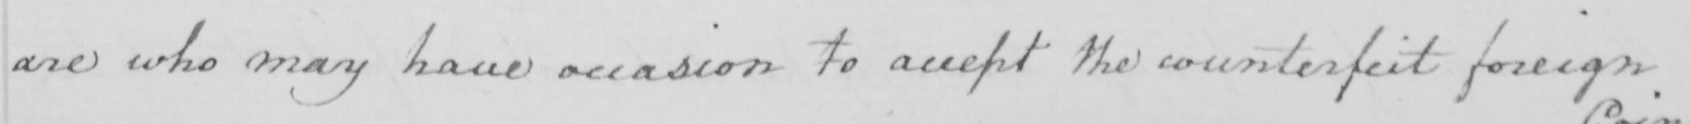Can you tell me what this handwritten text says? are who may have occasion to accept the counterfeit foreign 